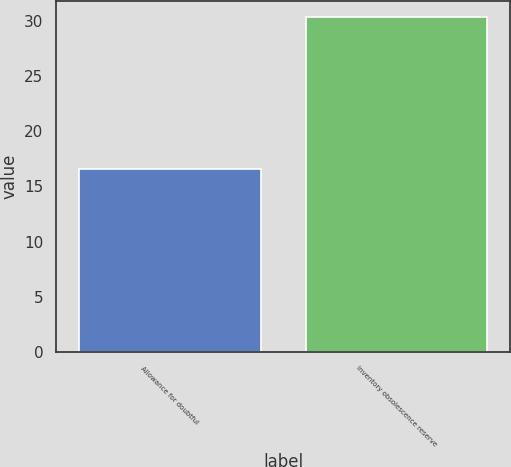Convert chart to OTSL. <chart><loc_0><loc_0><loc_500><loc_500><bar_chart><fcel>Allowance for doubtful<fcel>Inventory obsolescence reserve<nl><fcel>16.6<fcel>30.3<nl></chart> 